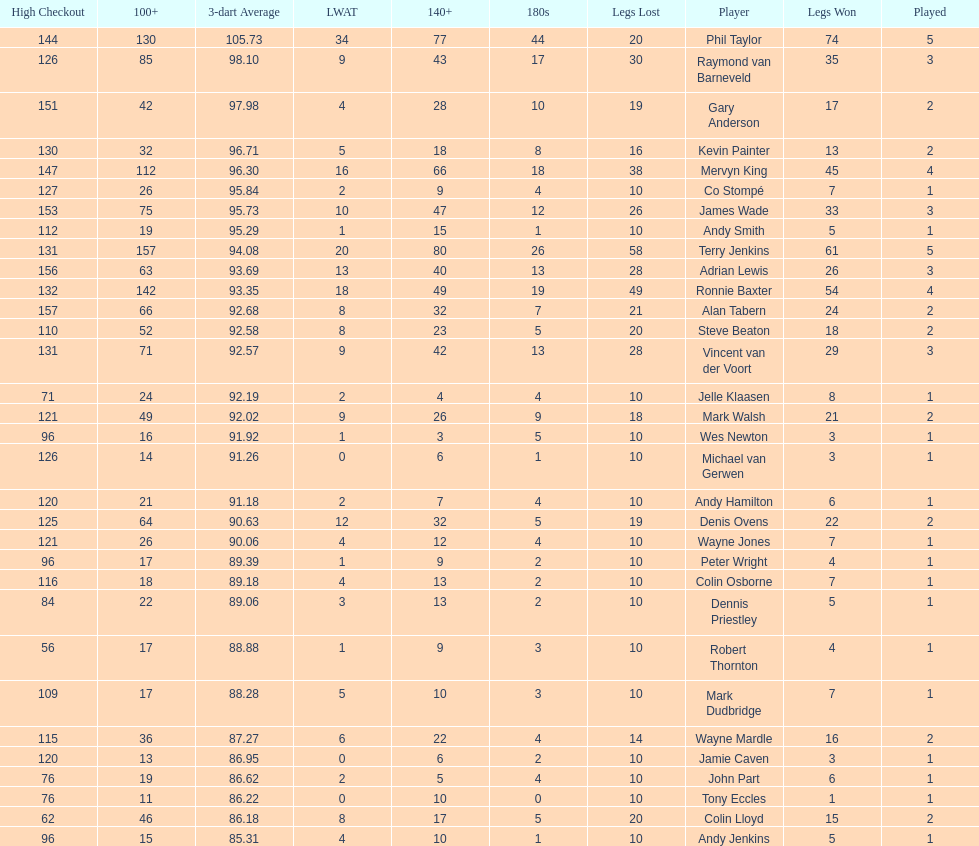What were the total number of legs won by ronnie baxter? 54. 